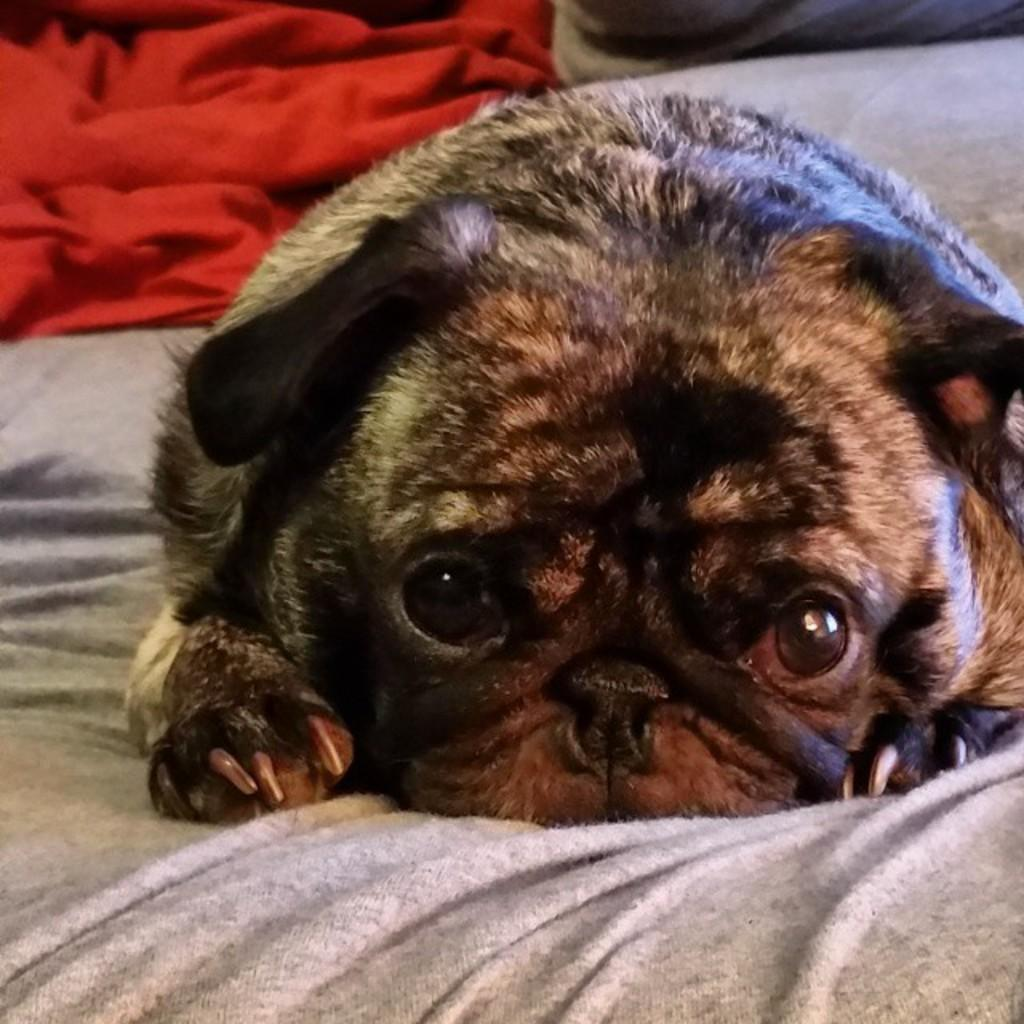Where was the image taken? The image is taken indoors. What furniture is present in the image? There is a bed in the image. What items are on the bed? The bed has a bed sheet, a blanket, and a pillow. What additional element is present on the bed? There is a dog on the bed. How many baseballs are visible on the bed in the image? There are no baseballs present in the image; it only features a bed with a bed sheet, a blanket, a pillow, and a dog. Are there any chairs visible in the image? There are no chairs visible in the image; the focus is on the bed and its contents. 